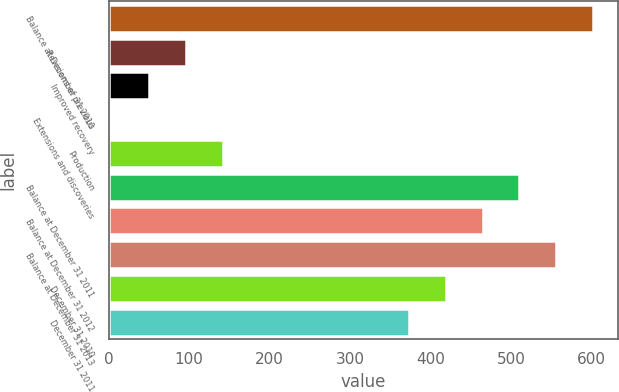Convert chart to OTSL. <chart><loc_0><loc_0><loc_500><loc_500><bar_chart><fcel>Balance at December 31 2010<fcel>Revisions of previous<fcel>Improved recovery<fcel>Extensions and discoveries<fcel>Production<fcel>Balance at December 31 2011<fcel>Balance at December 31 2012<fcel>Balance at December 31 2013<fcel>December 31 2010<fcel>December 31 2011<nl><fcel>602.3<fcel>95.9<fcel>50<fcel>3<fcel>141.8<fcel>510.5<fcel>464.6<fcel>556.4<fcel>418.7<fcel>372.8<nl></chart> 